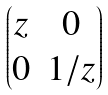Convert formula to latex. <formula><loc_0><loc_0><loc_500><loc_500>\begin{pmatrix} z & 0 \\ 0 & 1 / z \end{pmatrix}</formula> 